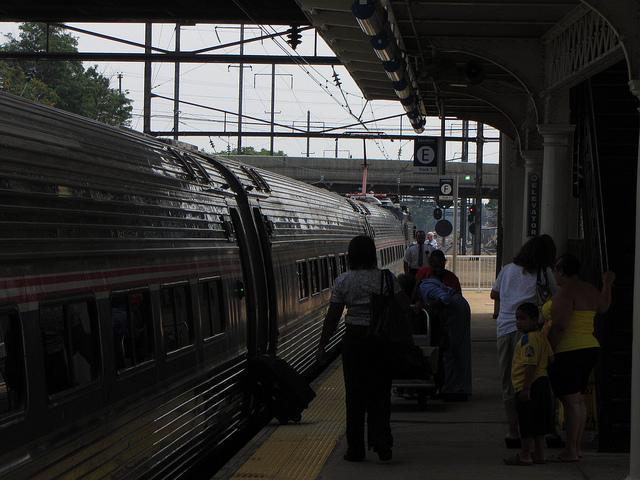What sort of power moves this vehicle?
Answer the question by selecting the correct answer among the 4 following choices and explain your choice with a short sentence. The answer should be formatted with the following format: `Answer: choice
Rationale: rationale.`
Options: Electric, diesel, gas, coal. Answer: electric.
Rationale: You can see all the wires criss-crossed over the train. 